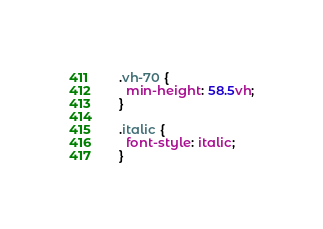Convert code to text. <code><loc_0><loc_0><loc_500><loc_500><_CSS_>.vh-70 {
  min-height: 58.5vh;
}

.italic {
  font-style: italic;
}
</code> 